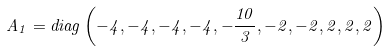<formula> <loc_0><loc_0><loc_500><loc_500>A _ { 1 } = d i a g \left ( - 4 , - 4 , - 4 , - 4 , - \frac { 1 0 } { 3 } , - 2 , - 2 , 2 , 2 , 2 \right )</formula> 